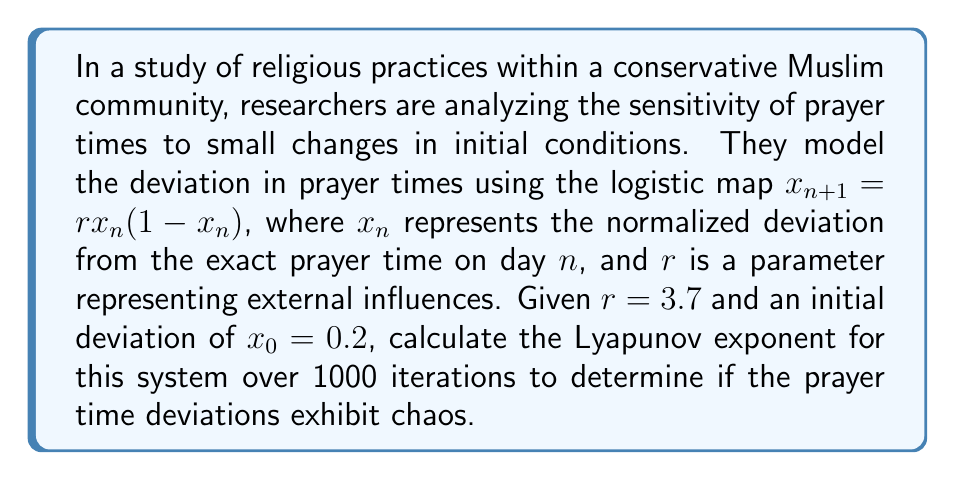What is the answer to this math problem? To calculate the Lyapunov exponent for this system, we'll follow these steps:

1) The Lyapunov exponent λ is given by:

   $$λ = \lim_{N \to \infty} \frac{1}{N} \sum_{n=0}^{N-1} \ln |f'(x_n)|$$

   where $f'(x)$ is the derivative of the logistic map.

2) For the logistic map $f(x) = rx(1-x)$, the derivative is:
   
   $$f'(x) = r(1-2x)$$

3) We need to iterate the map 1000 times and calculate $\ln|f'(x_n)|$ at each step:

   $x_0 = 0.2$
   $x_1 = 3.7 \cdot 0.2 \cdot (1-0.2) = 0.592$
   $x_2 = 3.7 \cdot 0.592 \cdot (1-0.592) = 0.892$
   ...continue for 1000 iterations

4) At each step, calculate:
   
   $$\ln|f'(x_n)| = \ln|3.7(1-2x_n)|$$

5) Sum these values and divide by 1000:

   $$λ ≈ \frac{1}{1000} \sum_{n=0}^{999} \ln|3.7(1-2x_n)|$$

6) Using a computer or calculator to perform these iterations and calculations, we get:

   $$λ ≈ 0.4936$$

7) Since λ > 0, the system exhibits chaotic behavior, indicating high sensitivity to initial conditions in prayer time deviations.
Answer: $λ ≈ 0.4936$ 